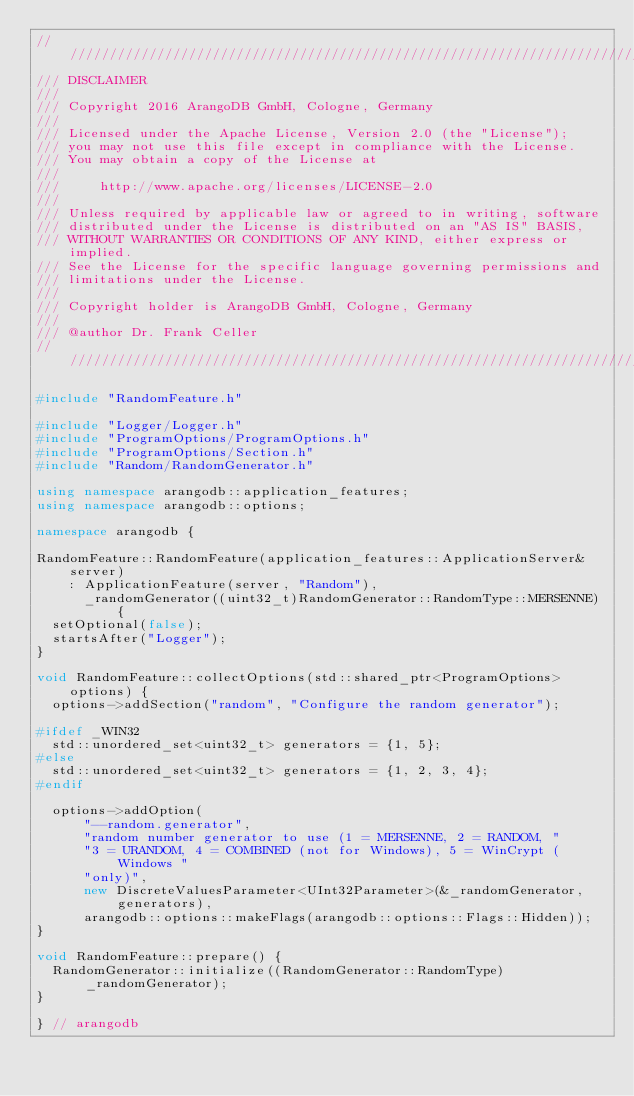<code> <loc_0><loc_0><loc_500><loc_500><_C++_>////////////////////////////////////////////////////////////////////////////////
/// DISCLAIMER
///
/// Copyright 2016 ArangoDB GmbH, Cologne, Germany
///
/// Licensed under the Apache License, Version 2.0 (the "License");
/// you may not use this file except in compliance with the License.
/// You may obtain a copy of the License at
///
///     http://www.apache.org/licenses/LICENSE-2.0
///
/// Unless required by applicable law or agreed to in writing, software
/// distributed under the License is distributed on an "AS IS" BASIS,
/// WITHOUT WARRANTIES OR CONDITIONS OF ANY KIND, either express or implied.
/// See the License for the specific language governing permissions and
/// limitations under the License.
///
/// Copyright holder is ArangoDB GmbH, Cologne, Germany
///
/// @author Dr. Frank Celler
////////////////////////////////////////////////////////////////////////////////

#include "RandomFeature.h"

#include "Logger/Logger.h"
#include "ProgramOptions/ProgramOptions.h"
#include "ProgramOptions/Section.h"
#include "Random/RandomGenerator.h"

using namespace arangodb::application_features;
using namespace arangodb::options;

namespace arangodb {

RandomFeature::RandomFeature(application_features::ApplicationServer& server)
    : ApplicationFeature(server, "Random"),
      _randomGenerator((uint32_t)RandomGenerator::RandomType::MERSENNE) {
  setOptional(false);
  startsAfter("Logger");
}

void RandomFeature::collectOptions(std::shared_ptr<ProgramOptions> options) {
  options->addSection("random", "Configure the random generator");

#ifdef _WIN32
  std::unordered_set<uint32_t> generators = {1, 5};
#else
  std::unordered_set<uint32_t> generators = {1, 2, 3, 4};
#endif

  options->addOption(
      "--random.generator",
      "random number generator to use (1 = MERSENNE, 2 = RANDOM, "
      "3 = URANDOM, 4 = COMBINED (not for Windows), 5 = WinCrypt (Windows "
      "only)",
      new DiscreteValuesParameter<UInt32Parameter>(&_randomGenerator, generators),
      arangodb::options::makeFlags(arangodb::options::Flags::Hidden));
}

void RandomFeature::prepare() {
  RandomGenerator::initialize((RandomGenerator::RandomType)_randomGenerator);
}

} // arangodb
</code> 